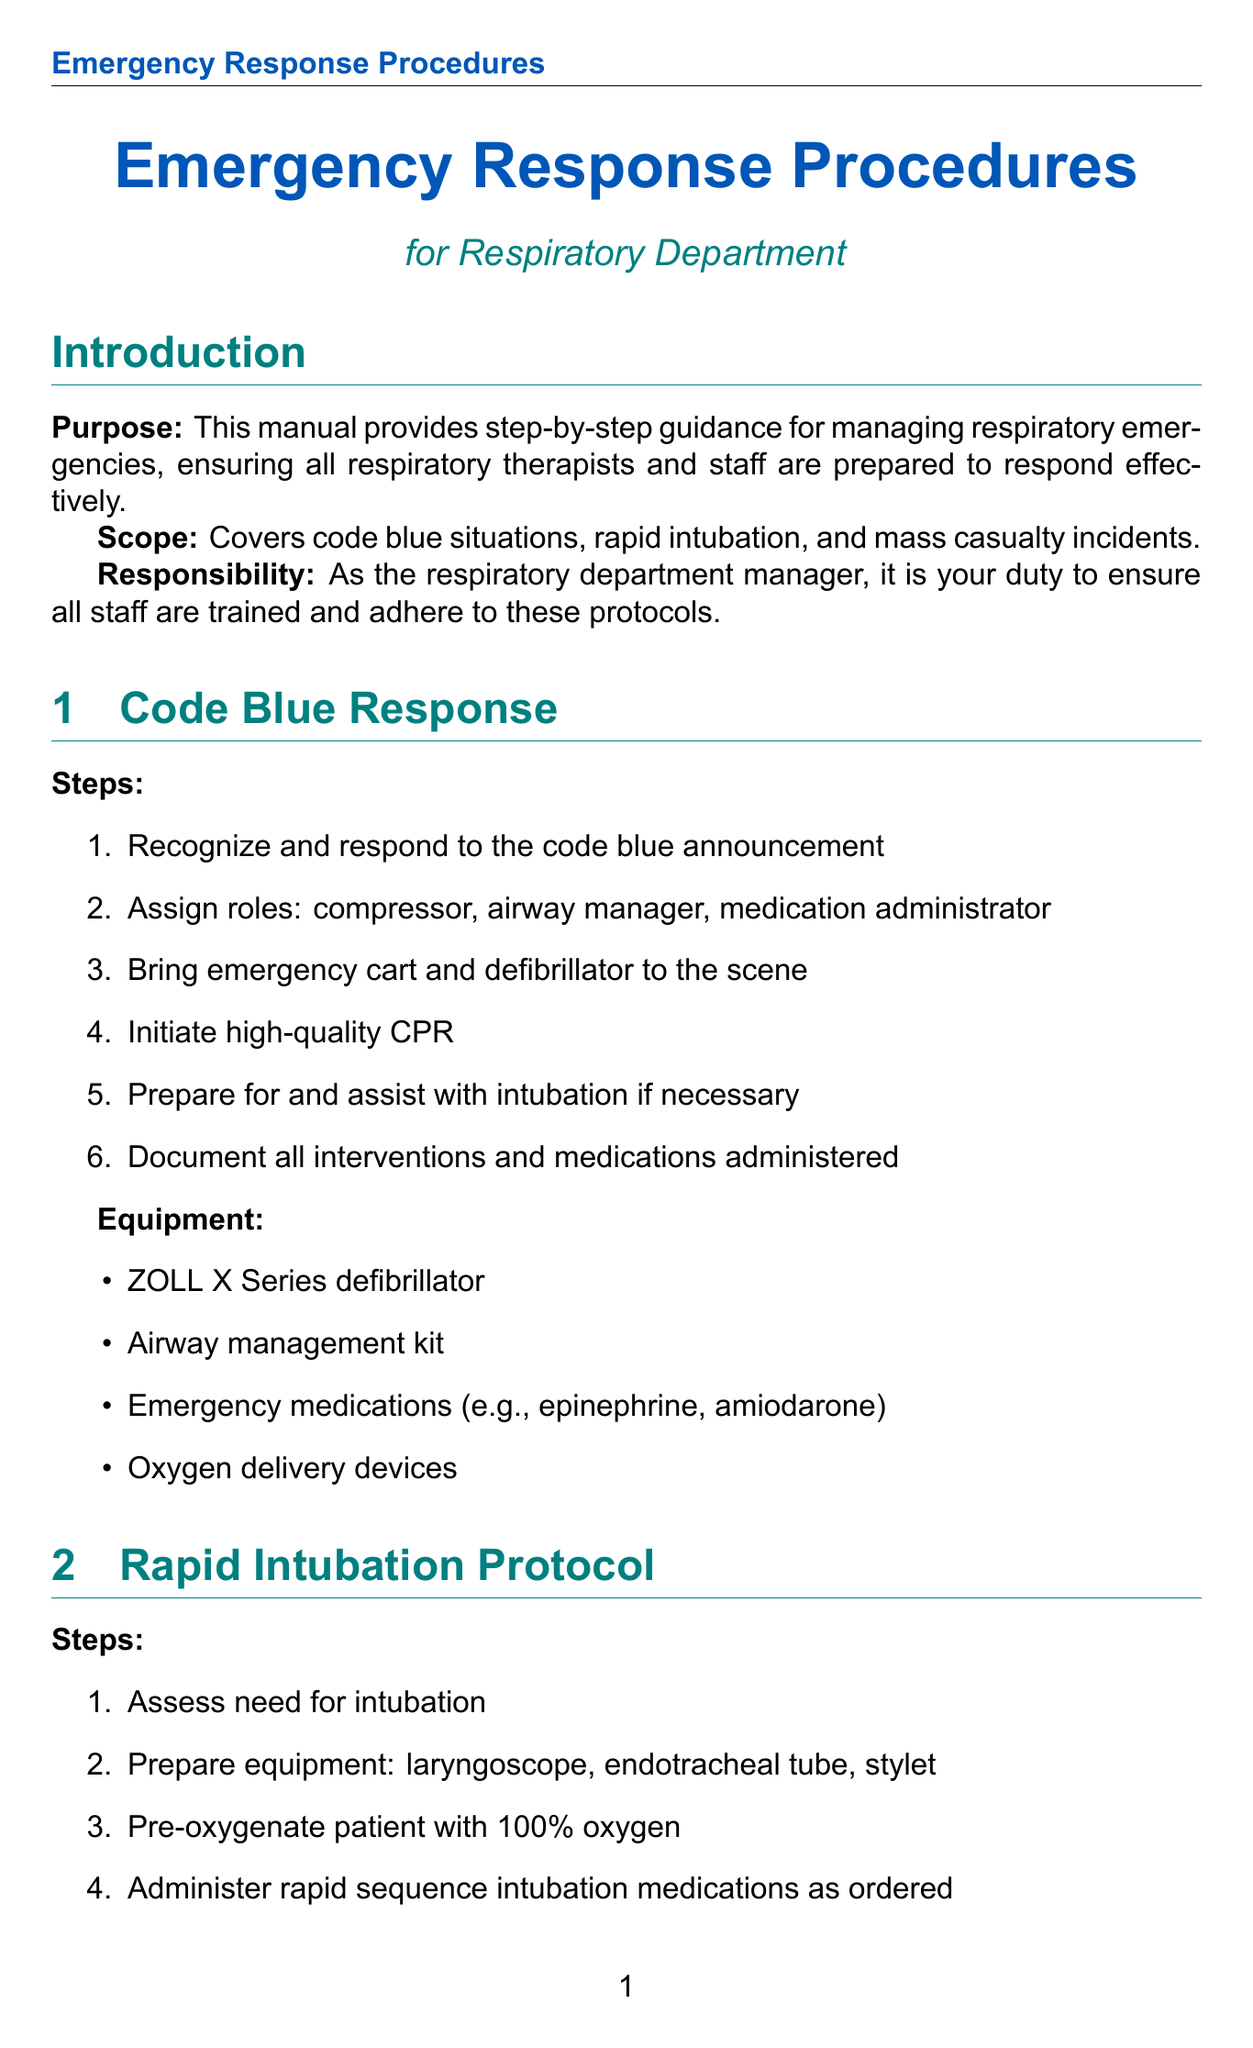What is the purpose of the manual? The purpose of the manual is to provide step-by-step guidance for managing respiratory emergencies, ensuring all respiratory therapists and staff are prepared to respond effectively.
Answer: step-by-step guidance for managing respiratory emergencies What equipment is needed for Code Blue Response? The manual lists specific equipment needed for Code Blue Response which includes several items.
Answer: ZOLL X Series defibrillator, airway management kit, emergency medications, oxygen delivery devices How often should training for code blue simulations occur? The document specifies the frequency of training requirements for staff.
Answer: Annual What is the first step in the Rapid Intubation Protocol? The manual outlines the steps for rapid intubation, starting with an assessment.
Answer: Assess need for intubation What method is used for triaging patients in a mass casualty incident? The document describes the method used for triaging patients specifically in mass casualty incidents.
Answer: START method What should be done after each emergency response? The manual emphasizes the importance of documentation and debriefing after incidents.
Answer: Conduct post-incident debriefings Which portable ventilators are mentioned in the mass casualty incident response? The document identifies specific resources used in mass casualty situations, specifically ventilators.
Answer: Philips Respironics Trilogy portable ventilators What criteria should be used for difficult airway assessment? The manual specifies a set of criteria to use when assessing difficult airways.
Answer: LEMON criteria 